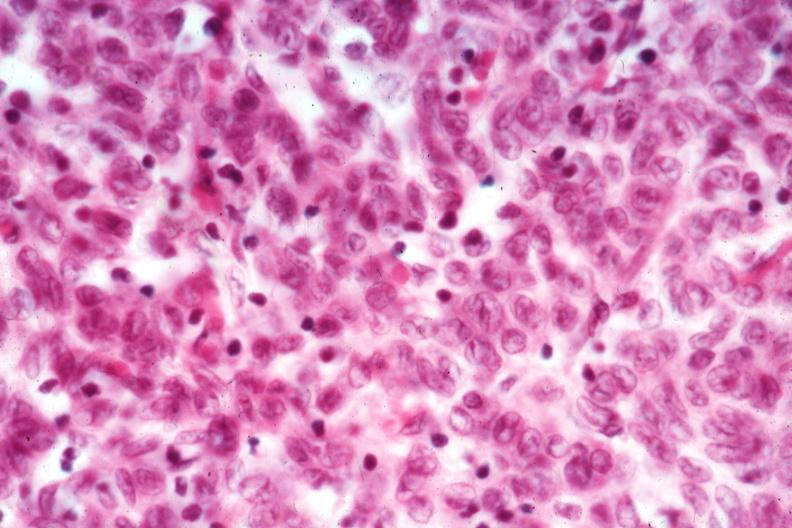s spina bifida present?
Answer the question using a single word or phrase. No 